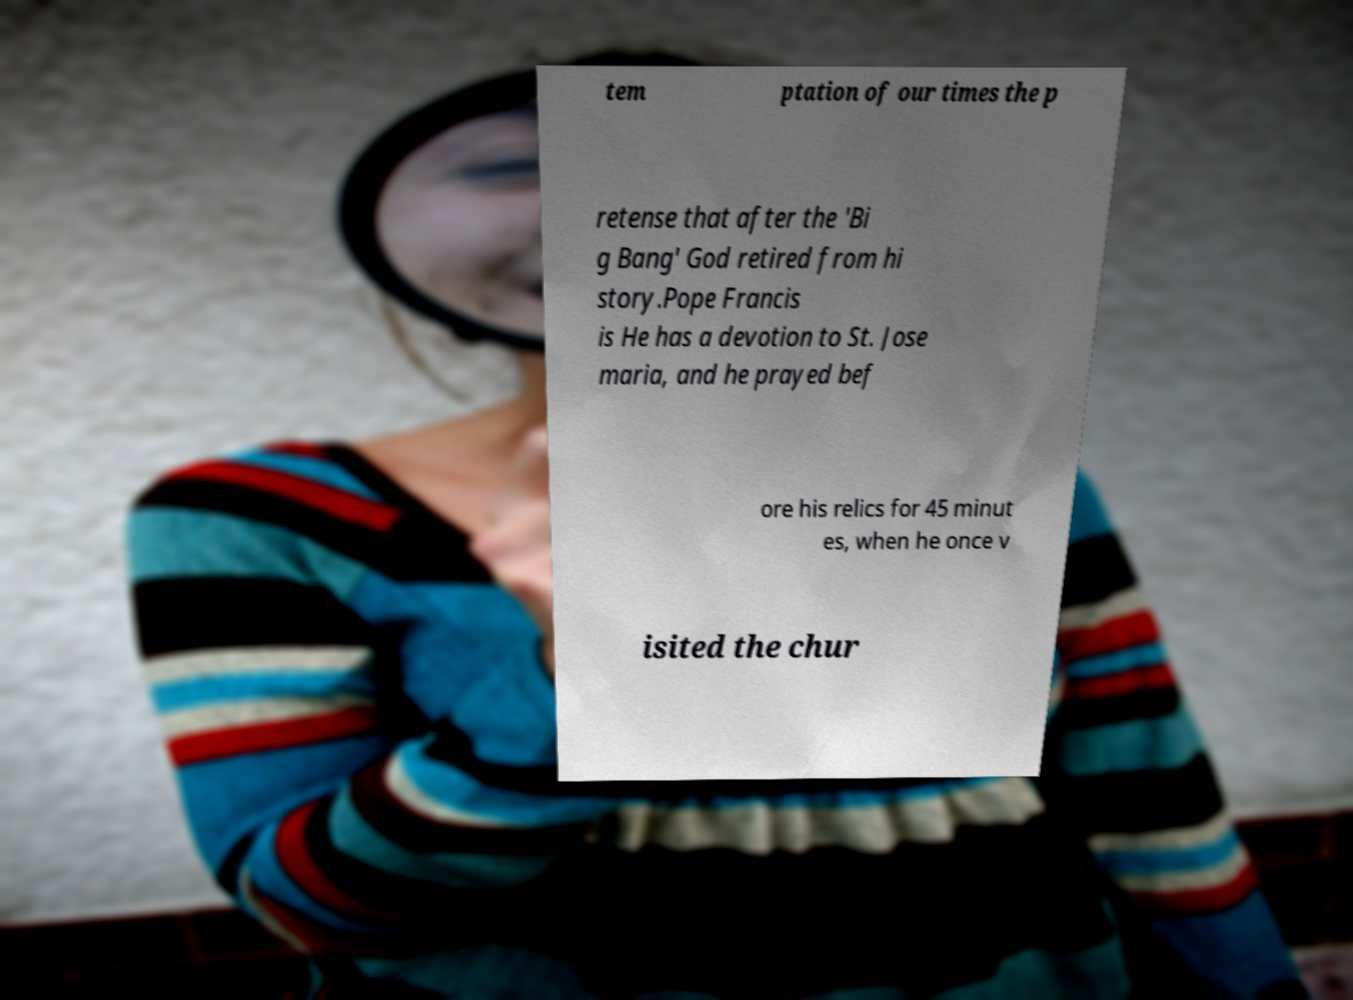Could you extract and type out the text from this image? tem ptation of our times the p retense that after the 'Bi g Bang' God retired from hi story.Pope Francis is He has a devotion to St. Jose maria, and he prayed bef ore his relics for 45 minut es, when he once v isited the chur 